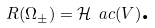Convert formula to latex. <formula><loc_0><loc_0><loc_500><loc_500>R ( \Omega _ { \pm } ) = \mathcal { H } _ { \ } a c ( V ) \text {.}</formula> 